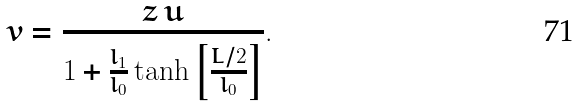<formula> <loc_0><loc_0><loc_500><loc_500>v = \frac { z \, u } { 1 + \frac { l _ { 1 } } { l _ { 0 } } \tanh \left [ \frac { L / 2 } { l _ { 0 } } \right ] } .</formula> 